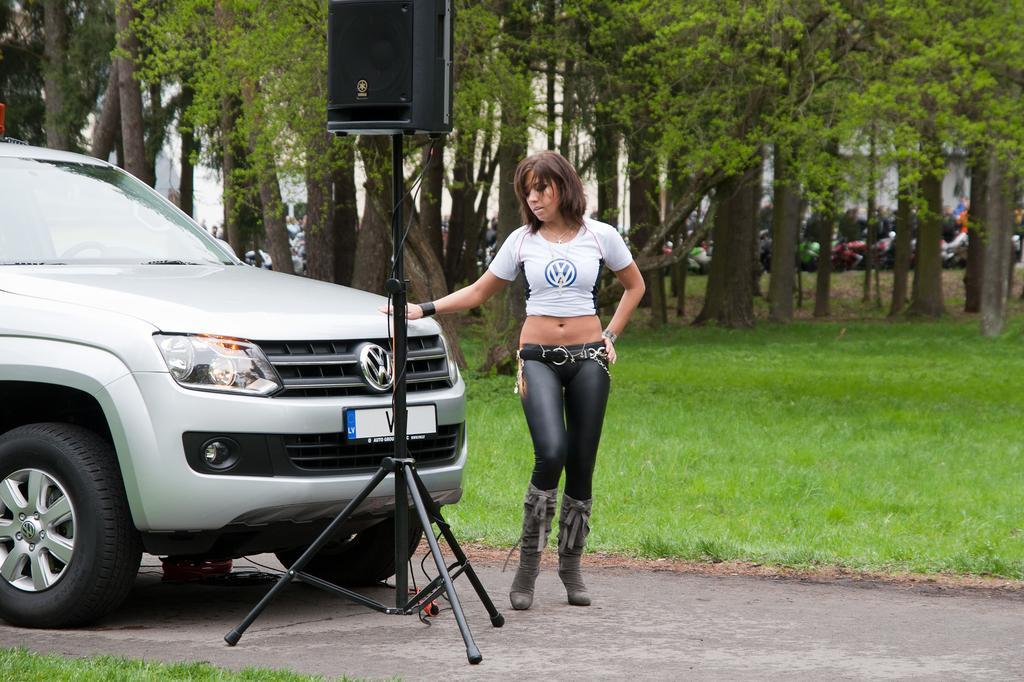Can you describe this image briefly? In the center of the image we can see woman standing at the car on the road. In the foreground we can see a speaker and stand. IN the background there is a grass, trees, building, and vehicles. 